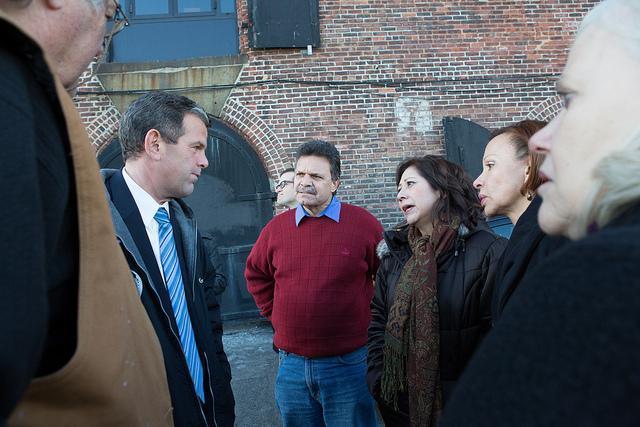How many people are present for this photograph?
Give a very brief answer. 6. How many people are in the picture?
Give a very brief answer. 6. How many elephants have trunk?
Give a very brief answer. 0. 